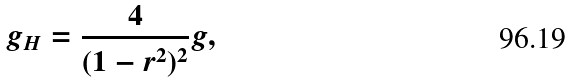Convert formula to latex. <formula><loc_0><loc_0><loc_500><loc_500>g _ { H } = \frac { 4 } { ( 1 - r ^ { 2 } ) ^ { 2 } } g ,</formula> 